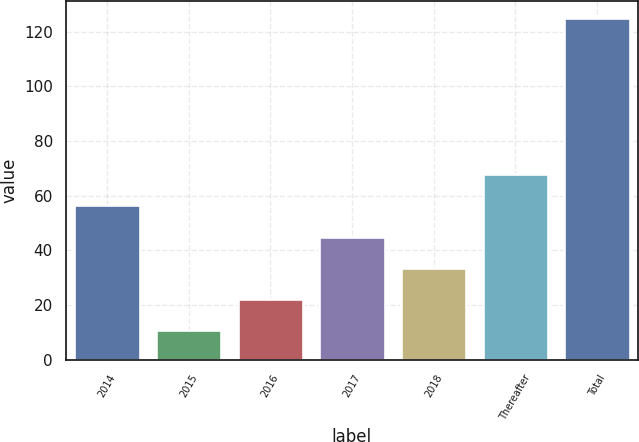Convert chart to OTSL. <chart><loc_0><loc_0><loc_500><loc_500><bar_chart><fcel>2014<fcel>2015<fcel>2016<fcel>2017<fcel>2018<fcel>Thereafter<fcel>Total<nl><fcel>56.44<fcel>10.8<fcel>22.21<fcel>45.03<fcel>33.62<fcel>67.85<fcel>124.9<nl></chart> 